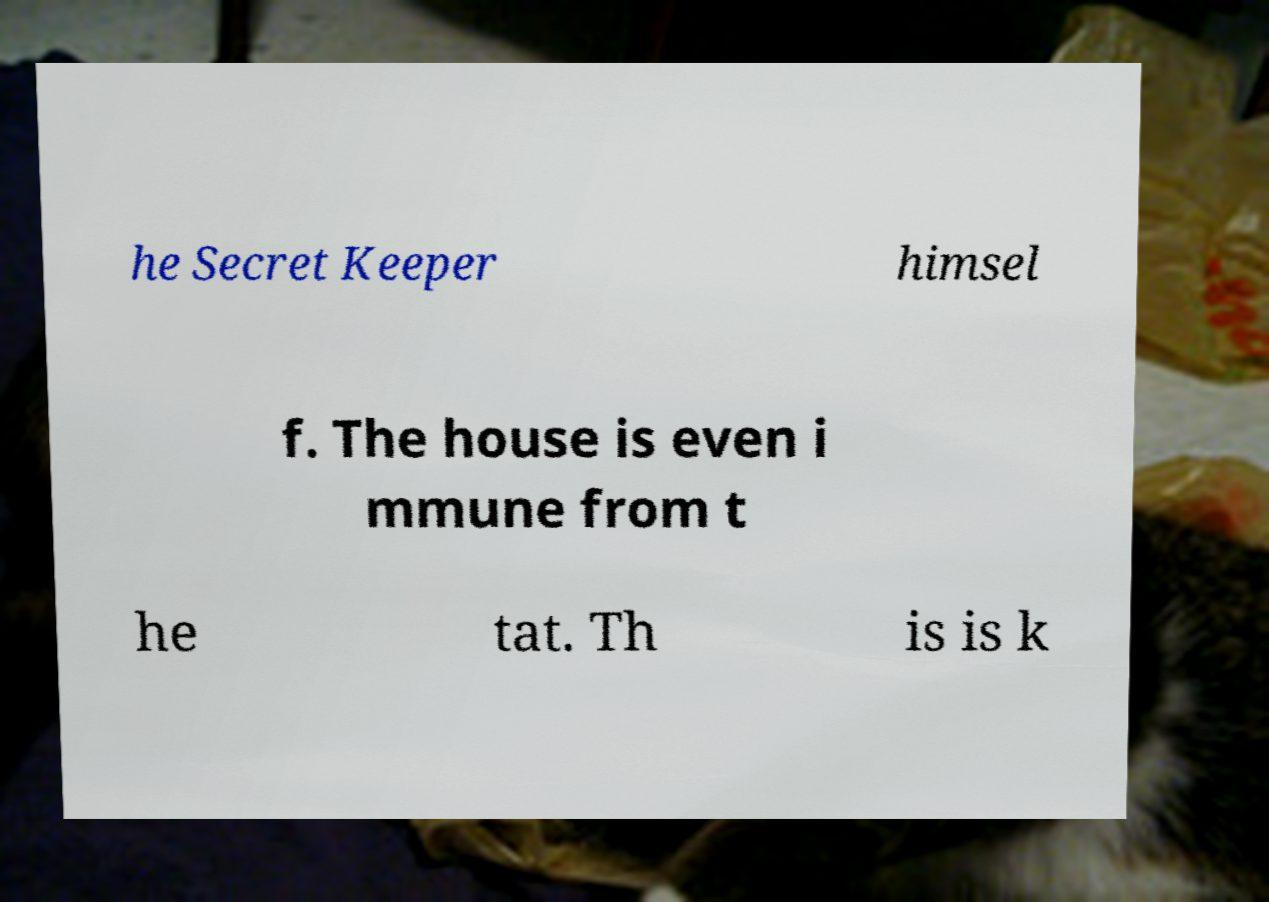For documentation purposes, I need the text within this image transcribed. Could you provide that? he Secret Keeper himsel f. The house is even i mmune from t he tat. Th is is k 